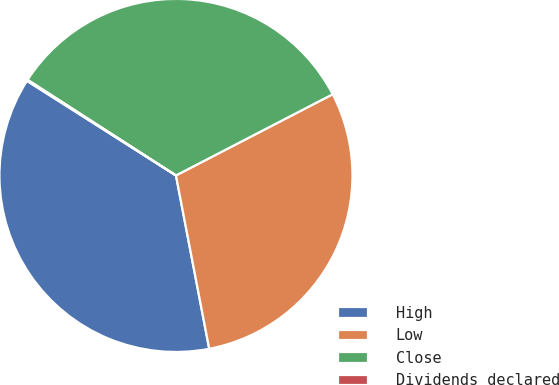Convert chart. <chart><loc_0><loc_0><loc_500><loc_500><pie_chart><fcel>High<fcel>Low<fcel>Close<fcel>Dividends declared<nl><fcel>37.02%<fcel>29.59%<fcel>33.28%<fcel>0.11%<nl></chart> 